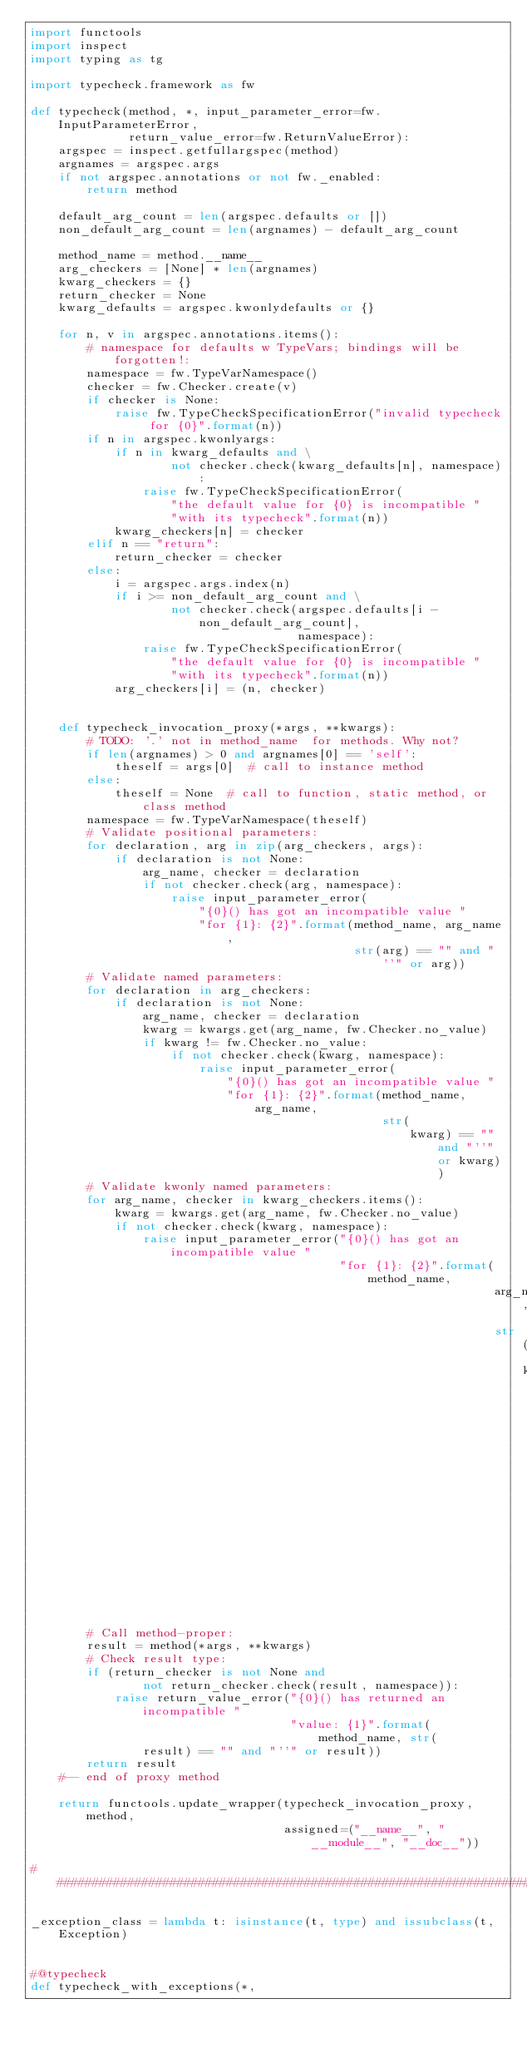<code> <loc_0><loc_0><loc_500><loc_500><_Python_>import functools
import inspect
import typing as tg

import typecheck.framework as fw

def typecheck(method, *, input_parameter_error=fw.InputParameterError,
              return_value_error=fw.ReturnValueError):
    argspec = inspect.getfullargspec(method)
    argnames = argspec.args
    if not argspec.annotations or not fw._enabled:
        return method

    default_arg_count = len(argspec.defaults or [])
    non_default_arg_count = len(argnames) - default_arg_count

    method_name = method.__name__
    arg_checkers = [None] * len(argnames)
    kwarg_checkers = {}
    return_checker = None
    kwarg_defaults = argspec.kwonlydefaults or {}

    for n, v in argspec.annotations.items():
        # namespace for defaults w TypeVars; bindings will be forgotten!:
        namespace = fw.TypeVarNamespace()
        checker = fw.Checker.create(v)
        if checker is None:
            raise fw.TypeCheckSpecificationError("invalid typecheck for {0}".format(n))
        if n in argspec.kwonlyargs:
            if n in kwarg_defaults and \
                    not checker.check(kwarg_defaults[n], namespace):
                raise fw.TypeCheckSpecificationError(
                    "the default value for {0} is incompatible "
                    "with its typecheck".format(n))
            kwarg_checkers[n] = checker
        elif n == "return":
            return_checker = checker
        else:
            i = argspec.args.index(n)
            if i >= non_default_arg_count and \
                    not checker.check(argspec.defaults[i - non_default_arg_count],
                                      namespace):
                raise fw.TypeCheckSpecificationError(
                    "the default value for {0} is incompatible "
                    "with its typecheck".format(n))
            arg_checkers[i] = (n, checker)


    def typecheck_invocation_proxy(*args, **kwargs):
        # TODO: '.' not in method_name  for methods. Why not?
        if len(argnames) > 0 and argnames[0] == 'self':
            theself = args[0]  # call to instance method
        else:
            theself = None  # call to function, static method, or class method
        namespace = fw.TypeVarNamespace(theself)
        # Validate positional parameters:
        for declaration, arg in zip(arg_checkers, args):
            if declaration is not None:
                arg_name, checker = declaration
                if not checker.check(arg, namespace):
                    raise input_parameter_error(
                        "{0}() has got an incompatible value "
                        "for {1}: {2}".format(method_name, arg_name,
                                              str(arg) == "" and "''" or arg))
        # Validate named parameters:
        for declaration in arg_checkers:
            if declaration is not None:
                arg_name, checker = declaration
                kwarg = kwargs.get(arg_name, fw.Checker.no_value)
                if kwarg != fw.Checker.no_value:
                    if not checker.check(kwarg, namespace):
                        raise input_parameter_error(
                            "{0}() has got an incompatible value "
                            "for {1}: {2}".format(method_name, arg_name,
                                                  str(
                                                      kwarg) == "" and "''" or kwarg))
        # Validate kwonly named parameters:
        for arg_name, checker in kwarg_checkers.items():
            kwarg = kwargs.get(arg_name, fw.Checker.no_value)
            if not checker.check(kwarg, namespace):
                raise input_parameter_error("{0}() has got an incompatible value "
                                            "for {1}: {2}".format(method_name,
                                                                  arg_name,
                                                                  str(
                                                                      kwarg) == "" and "''" or kwarg))
        # Call method-proper:
        result = method(*args, **kwargs)
        # Check result type:
        if (return_checker is not None and
                not return_checker.check(result, namespace)):
            raise return_value_error("{0}() has returned an incompatible "
                                     "value: {1}".format(method_name, str(
                result) == "" and "''" or result))
        return result
    #-- end of proxy method

    return functools.update_wrapper(typecheck_invocation_proxy, method,
                                    assigned=("__name__", "__module__", "__doc__"))

################################################################################

_exception_class = lambda t: isinstance(t, type) and issubclass(t, Exception)


#@typecheck
def typecheck_with_exceptions(*,</code> 